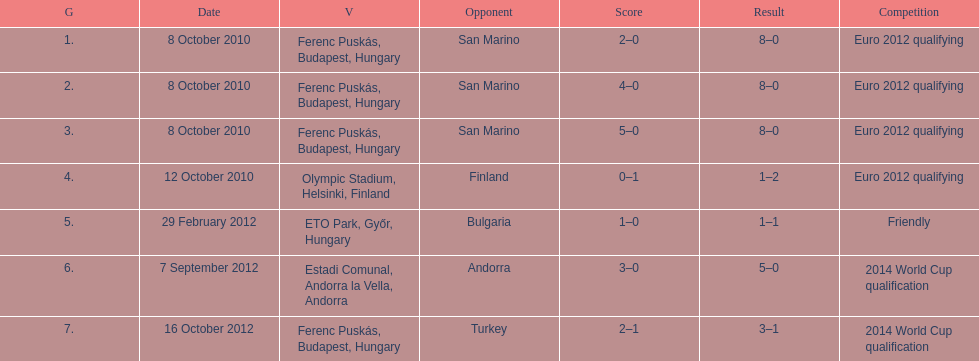What is the total number of international goals ádám szalai has made? 7. 